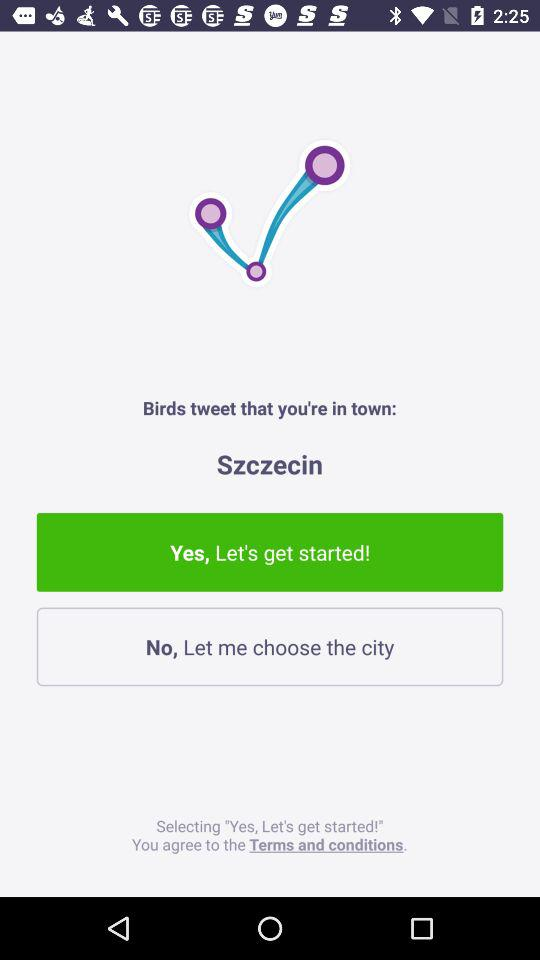What city name is shown? The shown city name is Szczecin. 